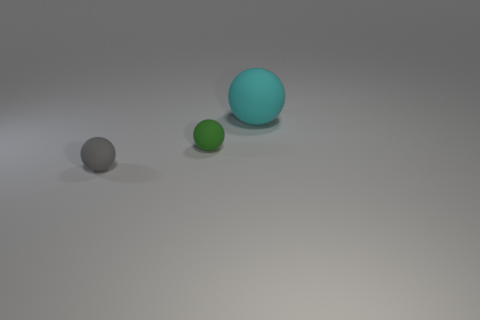Is there anything else that has the same size as the cyan rubber thing?
Provide a succinct answer. No. There is a ball behind the tiny thing that is behind the small matte object that is to the left of the tiny green matte object; what color is it?
Ensure brevity in your answer.  Cyan. There is a gray rubber thing that is the same size as the green matte object; what shape is it?
Provide a succinct answer. Sphere. Are there more gray matte blocks than small green spheres?
Offer a terse response. No. Is there a gray sphere behind the small matte object right of the gray thing?
Offer a very short reply. No. There is another big object that is the same shape as the green matte object; what is its color?
Offer a terse response. Cyan. What is the color of the other small thing that is made of the same material as the small gray object?
Provide a succinct answer. Green. Are there any small gray rubber objects on the left side of the rubber object in front of the green matte object behind the small gray ball?
Ensure brevity in your answer.  No. Is the number of green balls that are on the left side of the large cyan ball less than the number of rubber spheres on the right side of the gray rubber object?
Your answer should be very brief. Yes. How many tiny gray spheres have the same material as the green object?
Offer a very short reply. 1. 